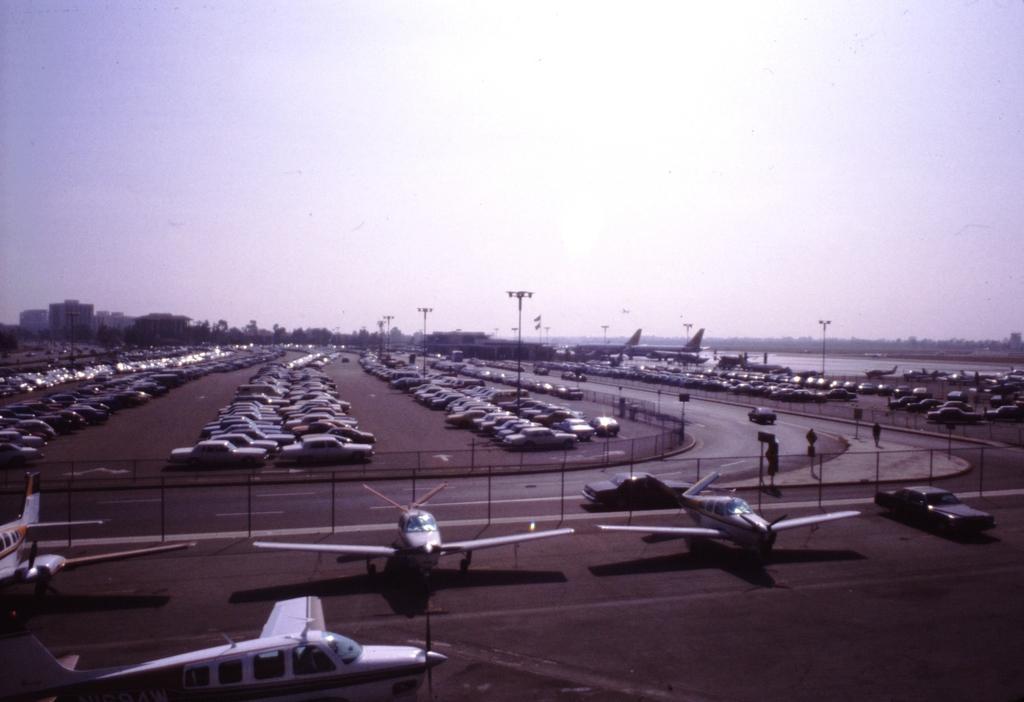Describe this image in one or two sentences. At the bottom of the picture, we see airplanes in the runway. Beside that, we see a fence and beside that, we see the vehicles are moving on the road. In the middle of the picture, we see the vehicles are parked on the road. On the right side, there are cars which are parked on the road. We even see street lights. There are buildings and trees in the background. At the top of the picture, we see the sky. 